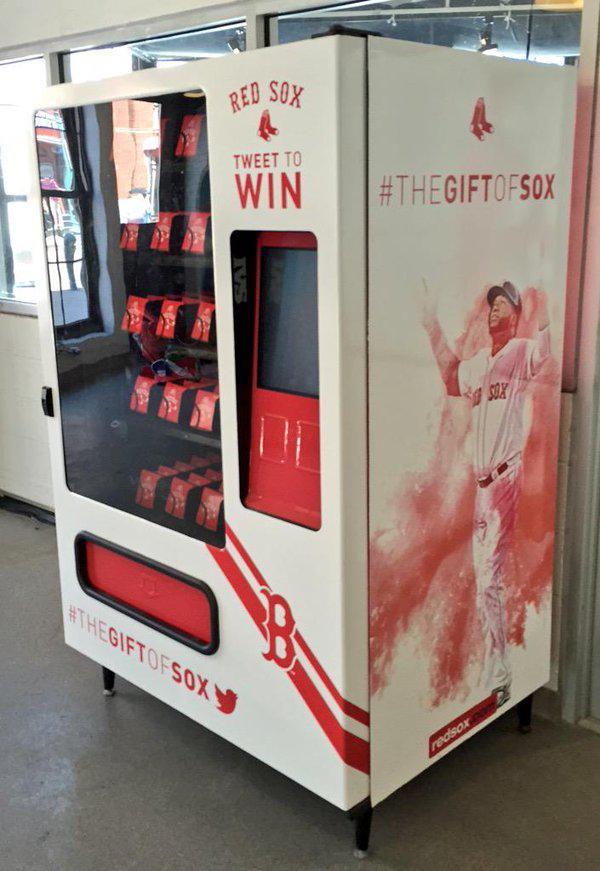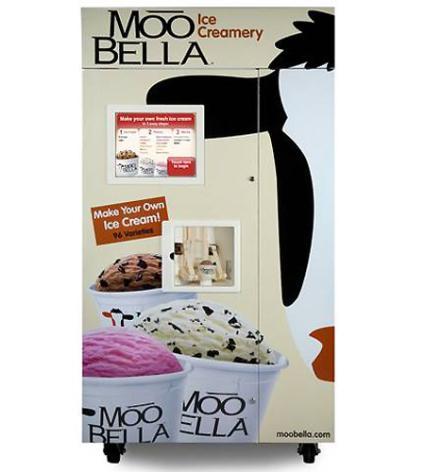The first image is the image on the left, the second image is the image on the right. Given the left and right images, does the statement "A vending machine has distinctive black and white markings." hold true? Answer yes or no. Yes. 